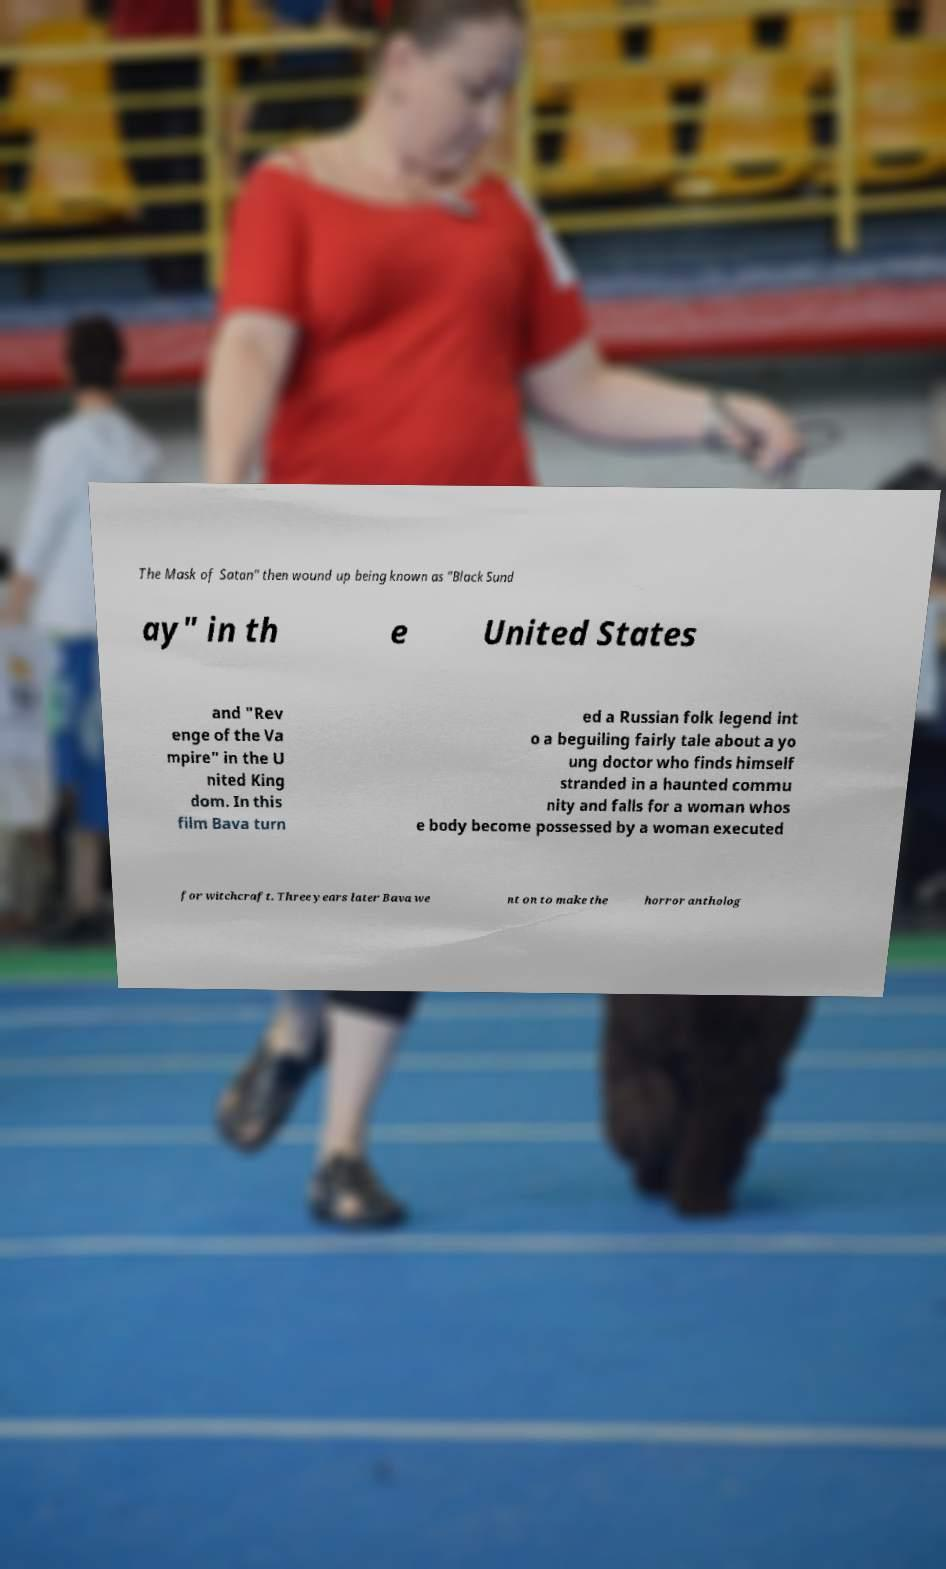I need the written content from this picture converted into text. Can you do that? The Mask of Satan" then wound up being known as "Black Sund ay" in th e United States and "Rev enge of the Va mpire" in the U nited King dom. In this film Bava turn ed a Russian folk legend int o a beguiling fairly tale about a yo ung doctor who finds himself stranded in a haunted commu nity and falls for a woman whos e body become possessed by a woman executed for witchcraft. Three years later Bava we nt on to make the horror antholog 